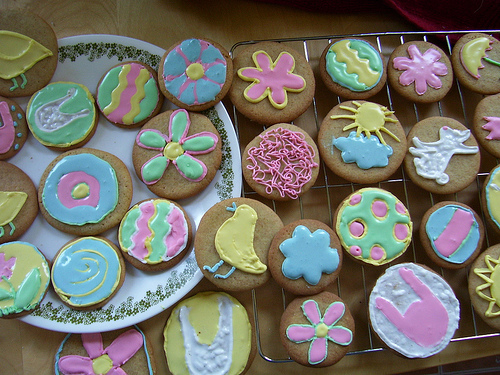<image>
Is the cookie under the cookie? No. The cookie is not positioned under the cookie. The vertical relationship between these objects is different. 